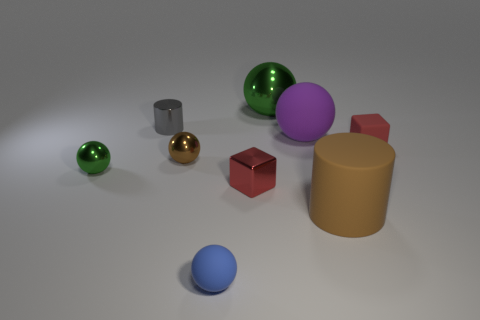Does the rubber cylinder have the same size as the red block behind the tiny green thing?
Ensure brevity in your answer.  No. What number of purple objects have the same size as the rubber cube?
Give a very brief answer. 0. What color is the other tiny sphere that is the same material as the tiny brown sphere?
Give a very brief answer. Green. Are there more brown metallic spheres than big red metal cylinders?
Offer a terse response. Yes. Are the large brown object and the small gray thing made of the same material?
Make the answer very short. No. There is a tiny blue thing that is made of the same material as the big purple thing; what is its shape?
Make the answer very short. Sphere. Is the number of small metallic balls less than the number of small green rubber objects?
Offer a terse response. No. What is the thing that is to the right of the gray cylinder and behind the purple matte ball made of?
Make the answer very short. Metal. There is a rubber sphere that is behind the green shiny ball in front of the green metal thing that is right of the metallic cylinder; what size is it?
Offer a very short reply. Large. Do the gray thing and the purple matte thing that is in front of the big green sphere have the same shape?
Offer a very short reply. No. 